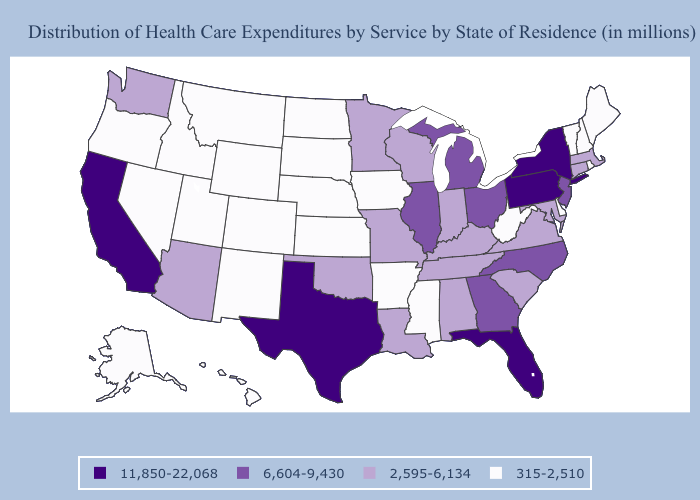What is the value of Florida?
Be succinct. 11,850-22,068. What is the lowest value in the USA?
Give a very brief answer. 315-2,510. Among the states that border Alabama , which have the lowest value?
Concise answer only. Mississippi. Does the map have missing data?
Concise answer only. No. What is the value of Oregon?
Quick response, please. 315-2,510. Name the states that have a value in the range 11,850-22,068?
Quick response, please. California, Florida, New York, Pennsylvania, Texas. Name the states that have a value in the range 315-2,510?
Short answer required. Alaska, Arkansas, Colorado, Delaware, Hawaii, Idaho, Iowa, Kansas, Maine, Mississippi, Montana, Nebraska, Nevada, New Hampshire, New Mexico, North Dakota, Oregon, Rhode Island, South Dakota, Utah, Vermont, West Virginia, Wyoming. What is the lowest value in the West?
Write a very short answer. 315-2,510. Does Wyoming have a lower value than Minnesota?
Write a very short answer. Yes. Which states hav the highest value in the Northeast?
Be succinct. New York, Pennsylvania. What is the value of North Dakota?
Quick response, please. 315-2,510. What is the value of Kansas?
Write a very short answer. 315-2,510. Among the states that border Massachusetts , which have the lowest value?
Answer briefly. New Hampshire, Rhode Island, Vermont. Does Vermont have the lowest value in the Northeast?
Answer briefly. Yes. What is the highest value in the USA?
Answer briefly. 11,850-22,068. 